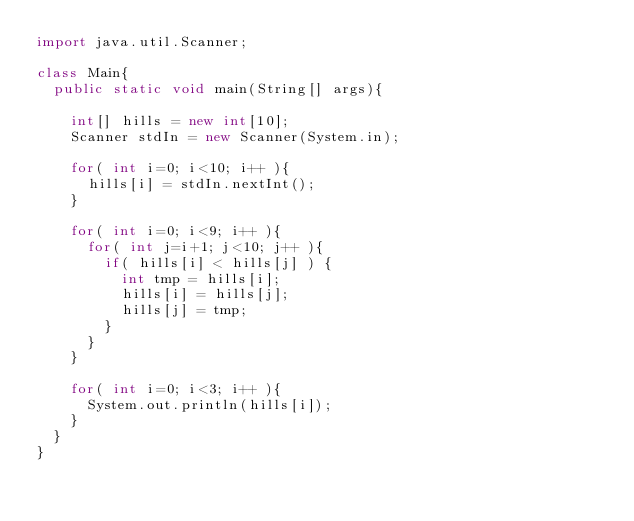<code> <loc_0><loc_0><loc_500><loc_500><_Java_>import java.util.Scanner;

class Main{
	public static void main(String[] args){

		int[] hills = new int[10];
		Scanner stdIn = new Scanner(System.in);

		for( int i=0; i<10; i++ ){
			hills[i] = stdIn.nextInt();
		}

		for( int i=0; i<9; i++ ){
			for( int j=i+1; j<10; j++ ){
				if( hills[i] < hills[j] ) {
					int tmp = hills[i];
					hills[i] = hills[j];
					hills[j] = tmp;
				}
			}
		}

		for( int i=0; i<3; i++ ){
			System.out.println(hills[i]);
		}
	}
}</code> 